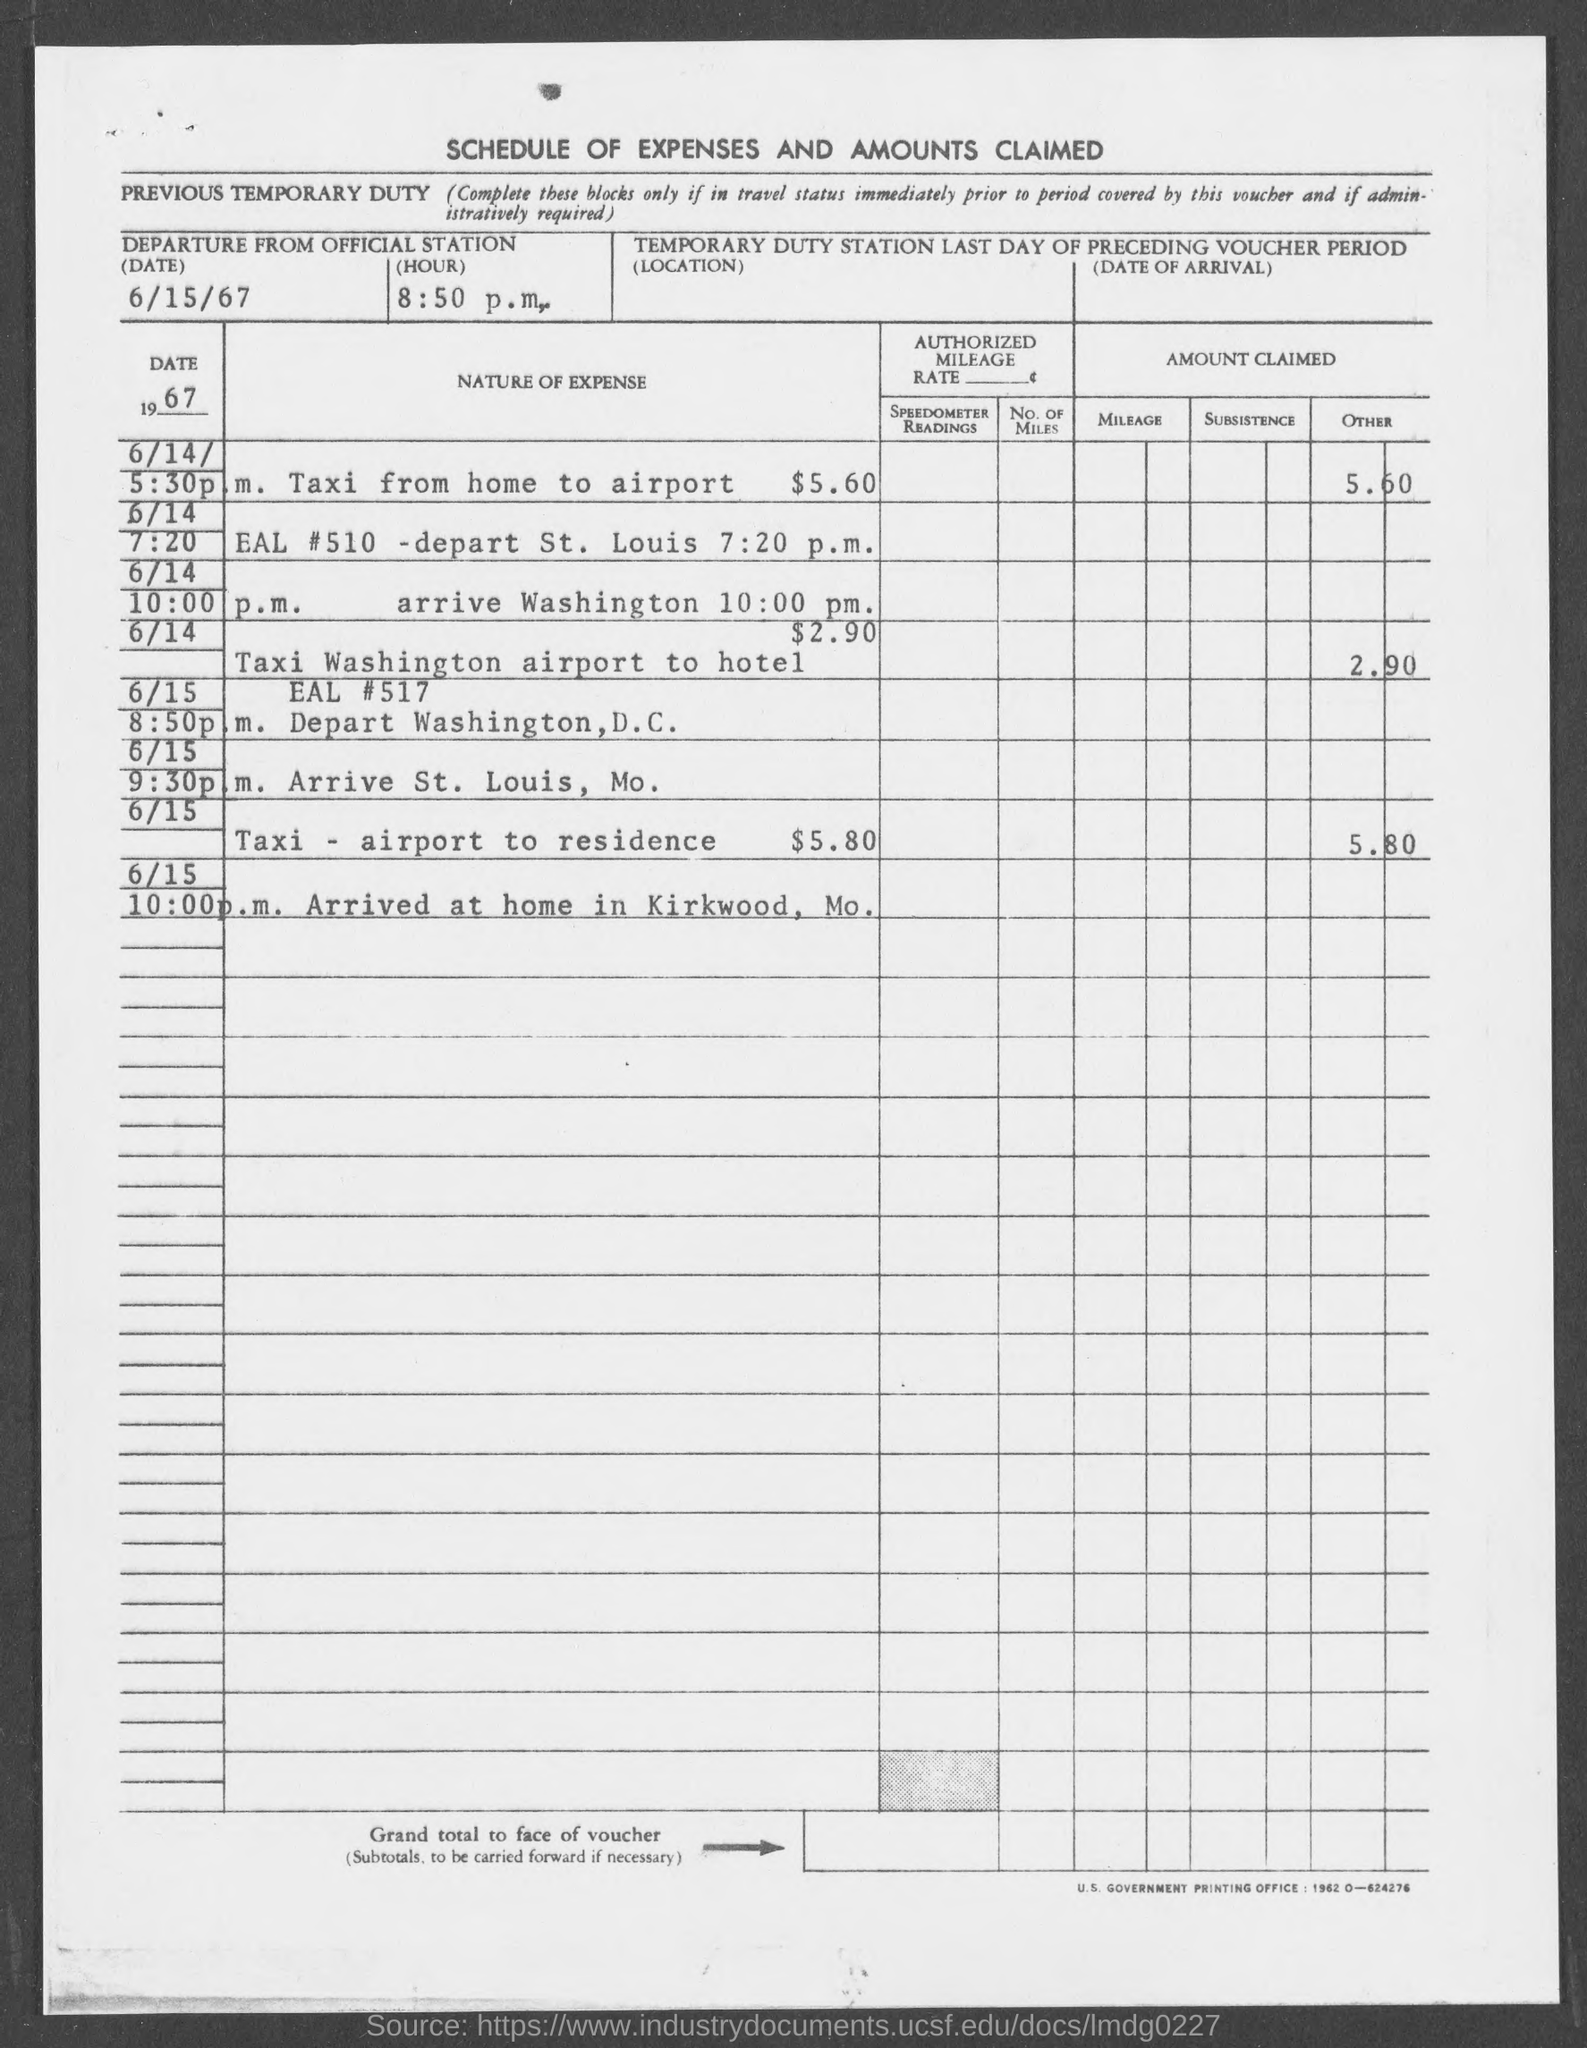What is the departure date mentioned in the given form ?
Offer a very short reply. 6/15/67. What is the departure time mentioned in the given form ?
Provide a succinct answer. 8:50 p.m. 